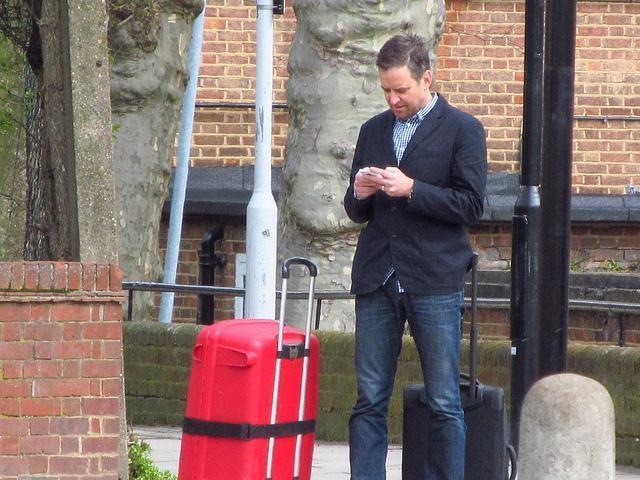How many suitcases can be seen?
Give a very brief answer. 2. How many train cars are shown in this picture?
Give a very brief answer. 0. 